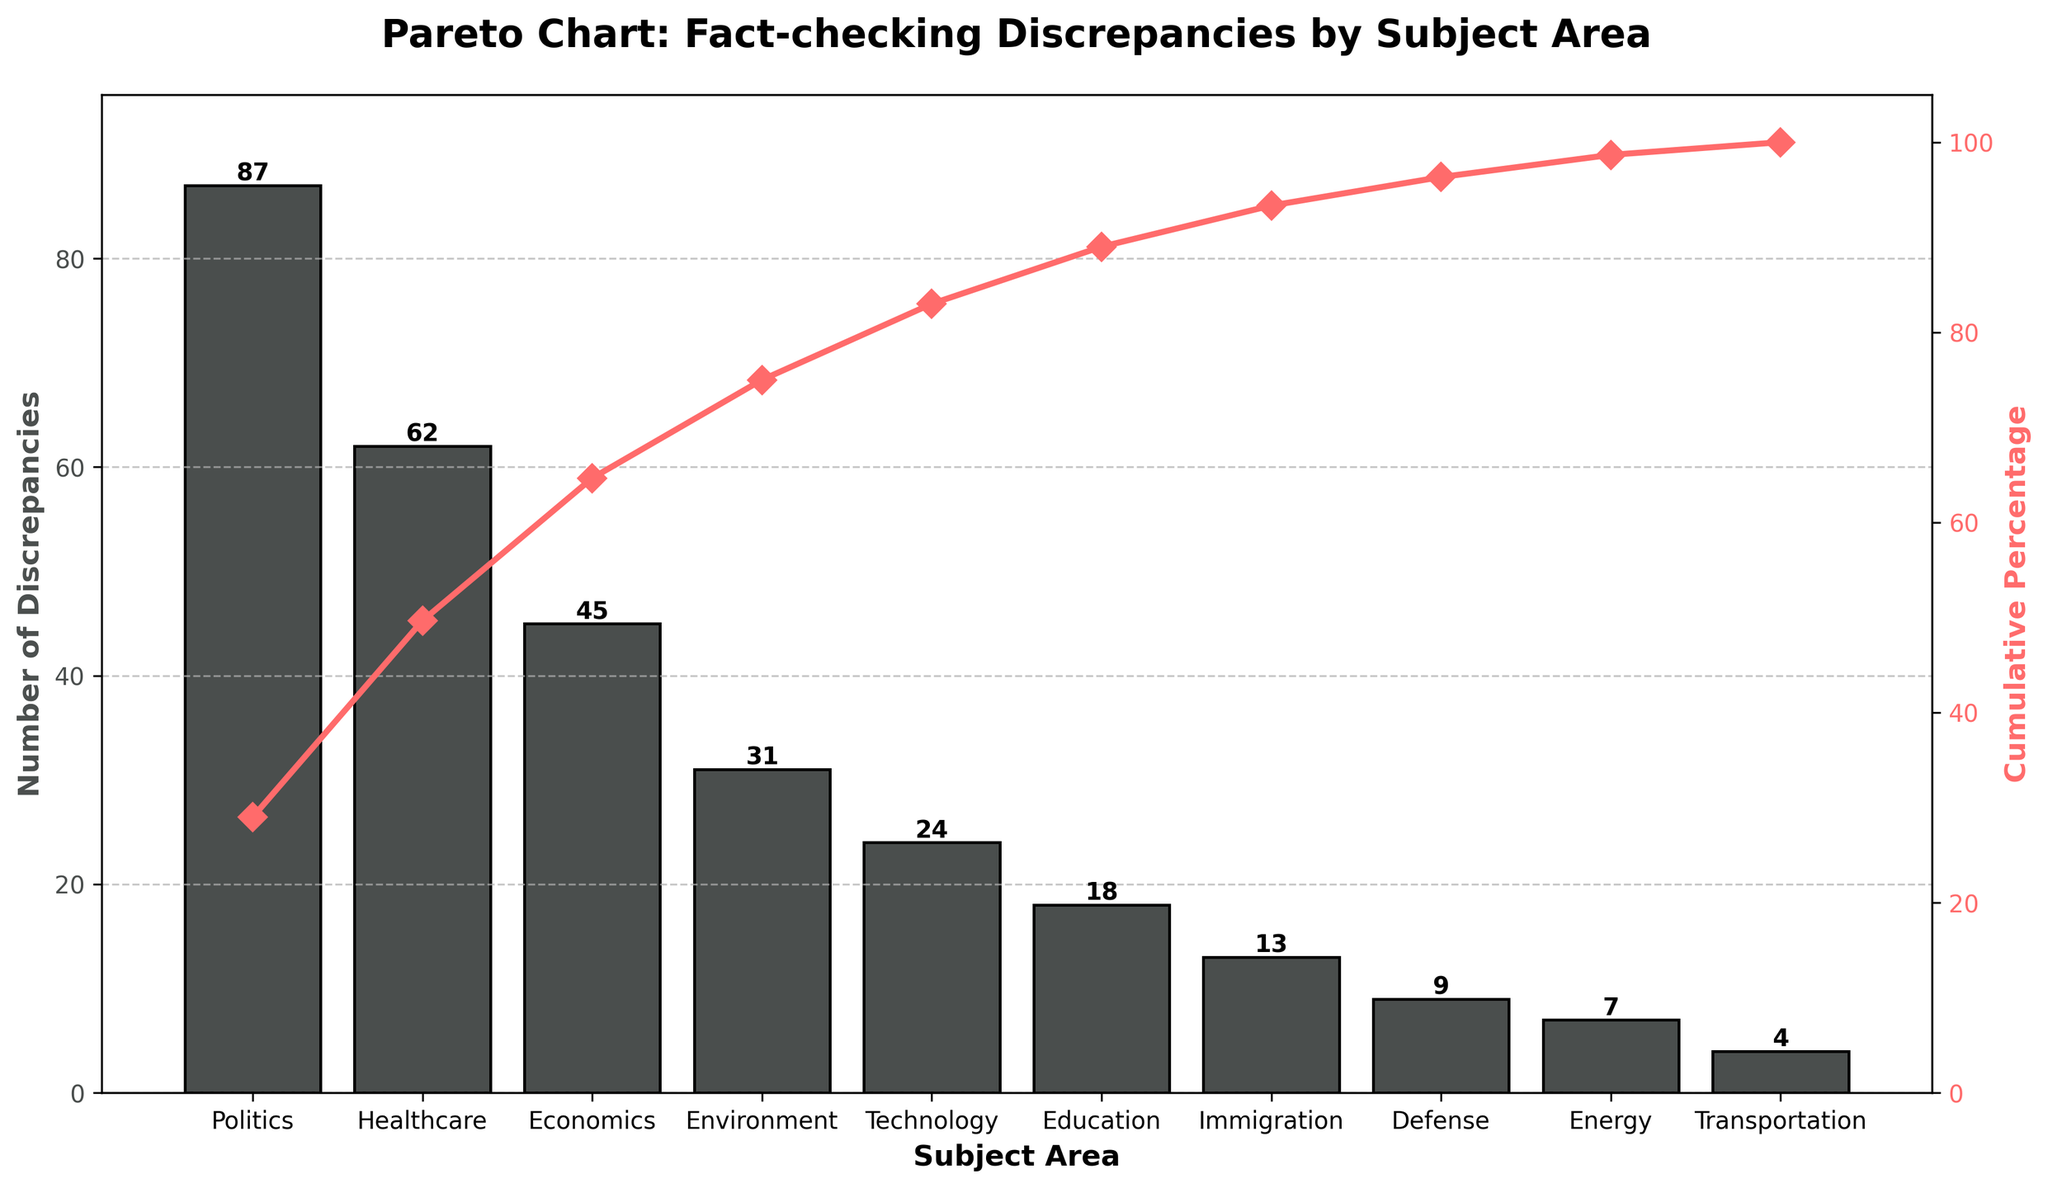What's the title of the figure? The title is located at the top of the chart and summarizes the content of the graph. By observing this section, we can identify that the title reads "Pareto Chart: Fact-checking Discrepancies by Subject Area".
Answer: Pareto Chart: Fact-checking Discrepancies by Subject Area What is the subject area with the highest number of discrepancies? We need to look at the height of each bar; the tallest bar represents the subject area with the highest number of discrepancies. The bar for Politics is the tallest, indicating it has the highest number of discrepancies.
Answer: Politics Compare the discrepancies in the Politics and Education subject areas. We observe the height of the bars for these two subject areas. The Politics bar is much higher (87 discrepancies) compared to the Education bar (18 discrepancies).
Answer: Politics has 69 more discrepancies than Education What percentage of the total discrepancies does the Healthcare subject area represent? Total discrepancies are found by summing all bar heights. Healthcare discrepancies are observed and divided by the total, then multiplied by 100. Total discrepancies = 87 + 62 + 45 + 31 + 24 + 18 + 13 + 9 + 7 + 4 = 300. Healthcare = 62. (62/300)*100 = 20.67%
Answer: 20.67% What is the cumulative percentage for the top three subject areas? We need to look at the cumulative percentage line and observe its value after the third subject bar (Economics). The cumulative percentage is at 64%.
Answer: 64% How does the cumulative percentage change from Technology to Education? Find the cumulative percentage at Technology and Education points. Technology ends at roughly 82%, and Education at around 88%, so the increase is approximately 6%.
Answer: 6% What pattern does the cumulative percentage line show? The line starts from 0% and rises steeply before flattening out, indicating that the first few subject areas account for most discrepancies, while the remaining add little incrementally to the cumulative total.
Answer: Steep rise followed by flattening How many subject areas have fewer discrepancies than Immigration? Observing the bars shorter than the Immigration bar (13 discrepancies), we see that Defense, Energy, and Transportation have fewer discrepancies.
Answer: 3 subject areas What's the discrepancy difference between Defense and Environment? Calculate the differences in bar heights; Defense is 9 and Environment is 31. The difference is 31 - 9 = 22.
Answer: 22 What color and pattern are used for the bar chart and cumulative percentage line? Observing the visual styling, the bars are colored gray with black edges, and the cumulative percentage line is red with diamond markers.
Answer: Gray bars with black edges; Red line with diamond markers 